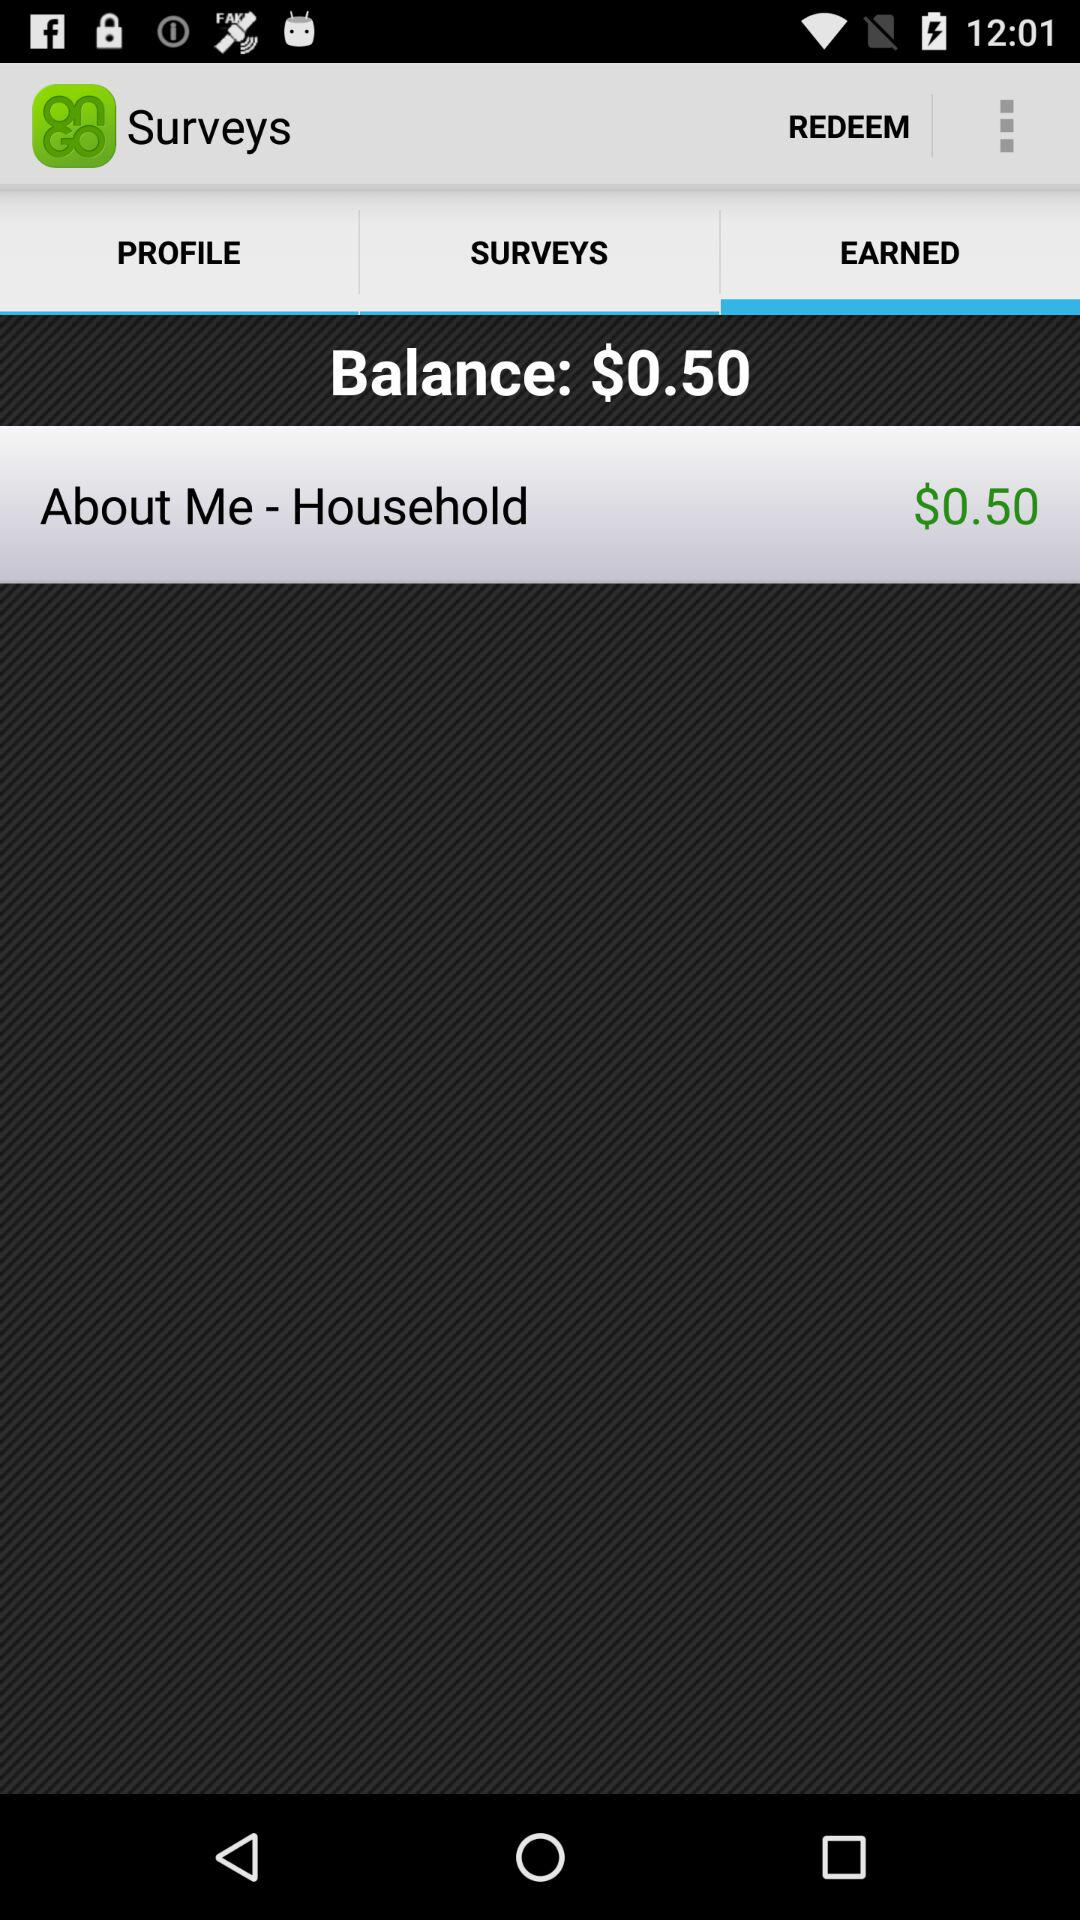What's the balance? The balance is $0.50. 